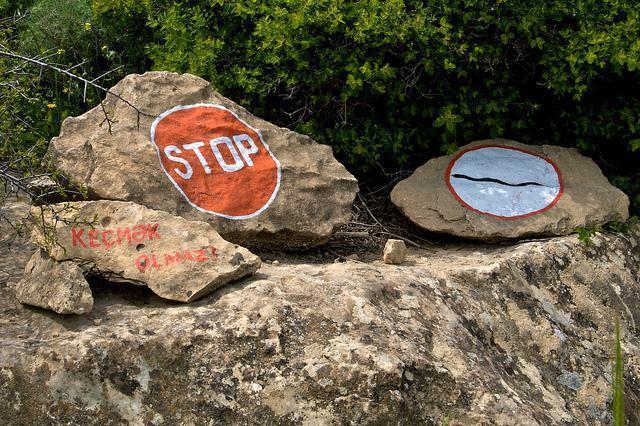How many people are wearing yellow jerseys?
Give a very brief answer. 0. 